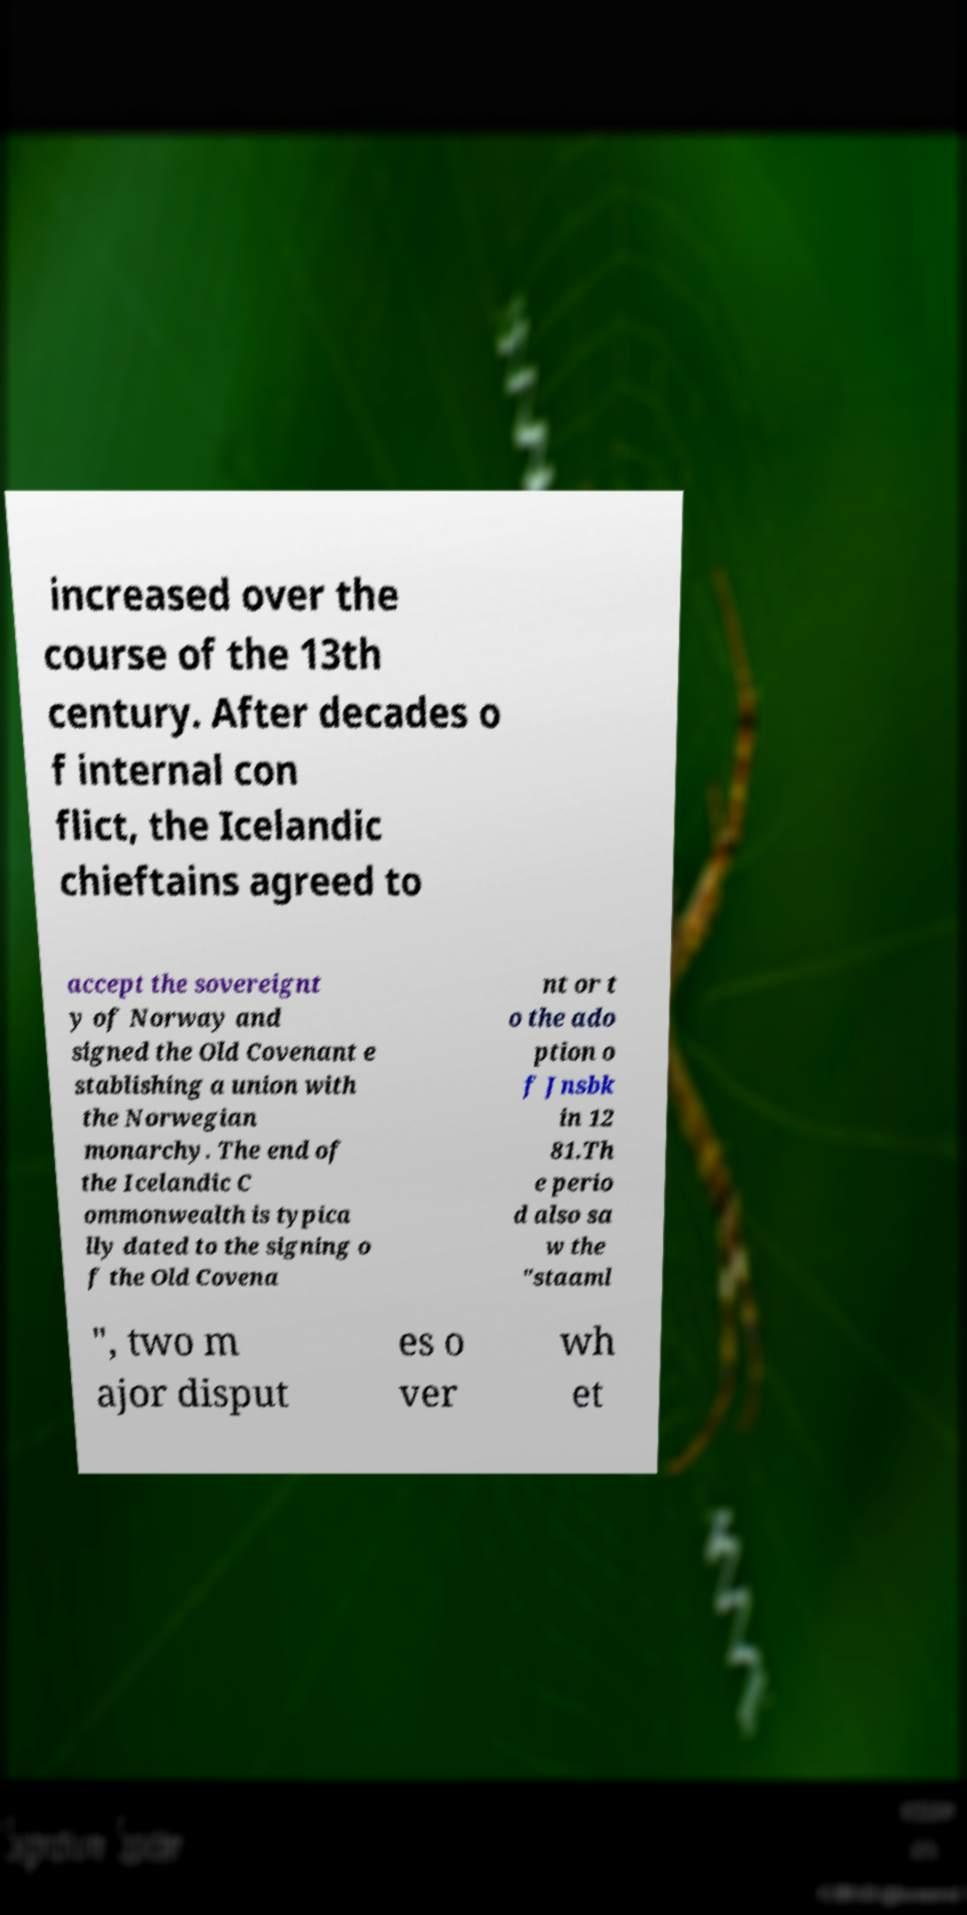Could you assist in decoding the text presented in this image and type it out clearly? increased over the course of the 13th century. After decades o f internal con flict, the Icelandic chieftains agreed to accept the sovereignt y of Norway and signed the Old Covenant e stablishing a union with the Norwegian monarchy. The end of the Icelandic C ommonwealth is typica lly dated to the signing o f the Old Covena nt or t o the ado ption o f Jnsbk in 12 81.Th e perio d also sa w the "staaml ", two m ajor disput es o ver wh et 